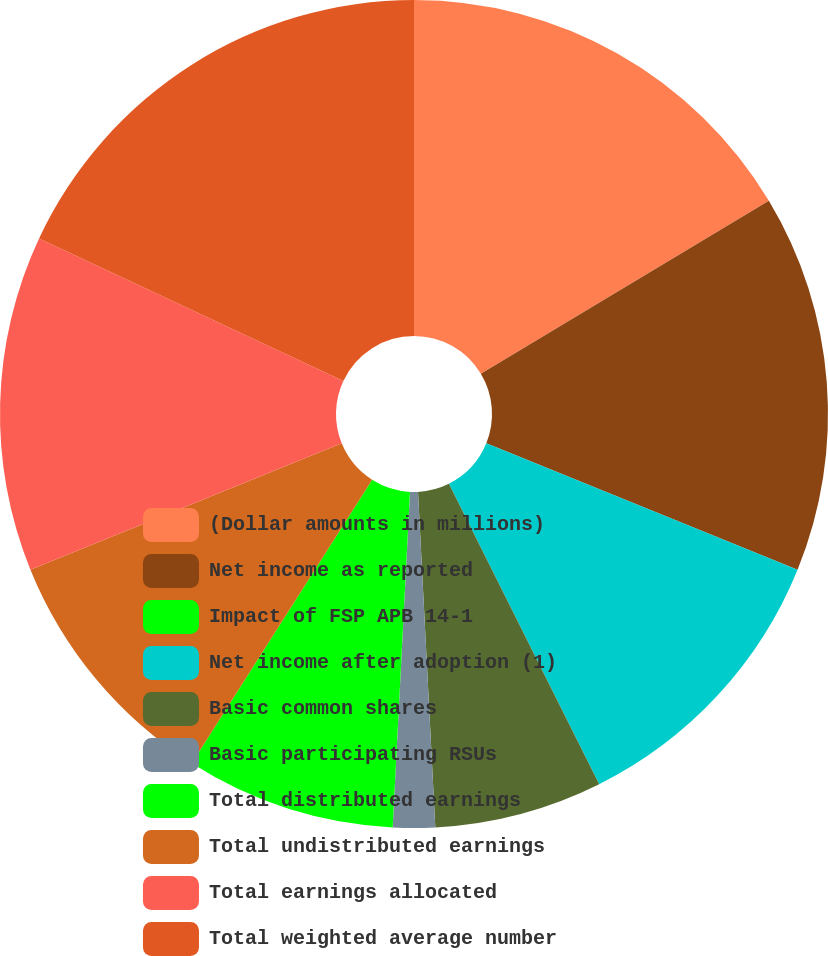Convert chart to OTSL. <chart><loc_0><loc_0><loc_500><loc_500><pie_chart><fcel>(Dollar amounts in millions)<fcel>Net income as reported<fcel>Impact of FSP APB 14-1<fcel>Net income after adoption (1)<fcel>Basic common shares<fcel>Basic participating RSUs<fcel>Total distributed earnings<fcel>Total undistributed earnings<fcel>Total earnings allocated<fcel>Total weighted average number<nl><fcel>16.39%<fcel>14.75%<fcel>0.0%<fcel>11.48%<fcel>6.56%<fcel>1.64%<fcel>8.2%<fcel>9.84%<fcel>13.11%<fcel>18.03%<nl></chart> 